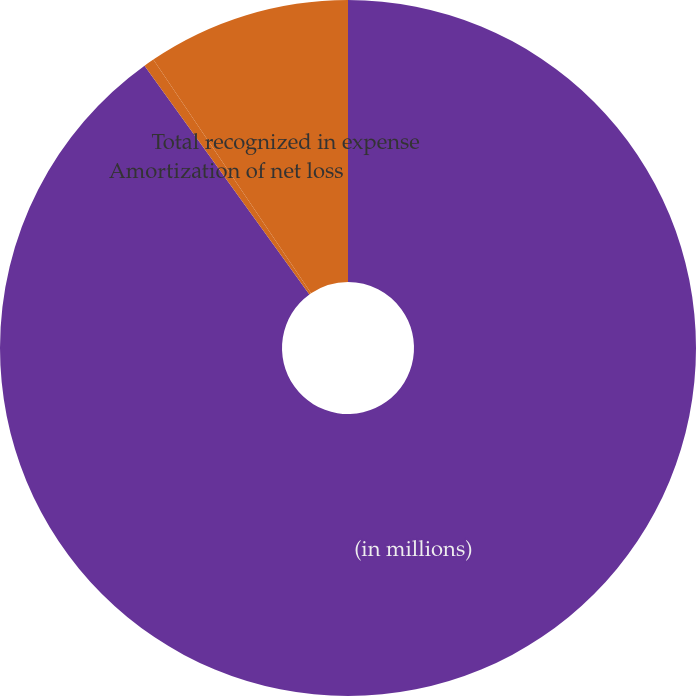<chart> <loc_0><loc_0><loc_500><loc_500><pie_chart><fcel>(in millions)<fcel>Amortization of net loss<fcel>Total recognized in expense<nl><fcel>90.06%<fcel>0.49%<fcel>9.45%<nl></chart> 